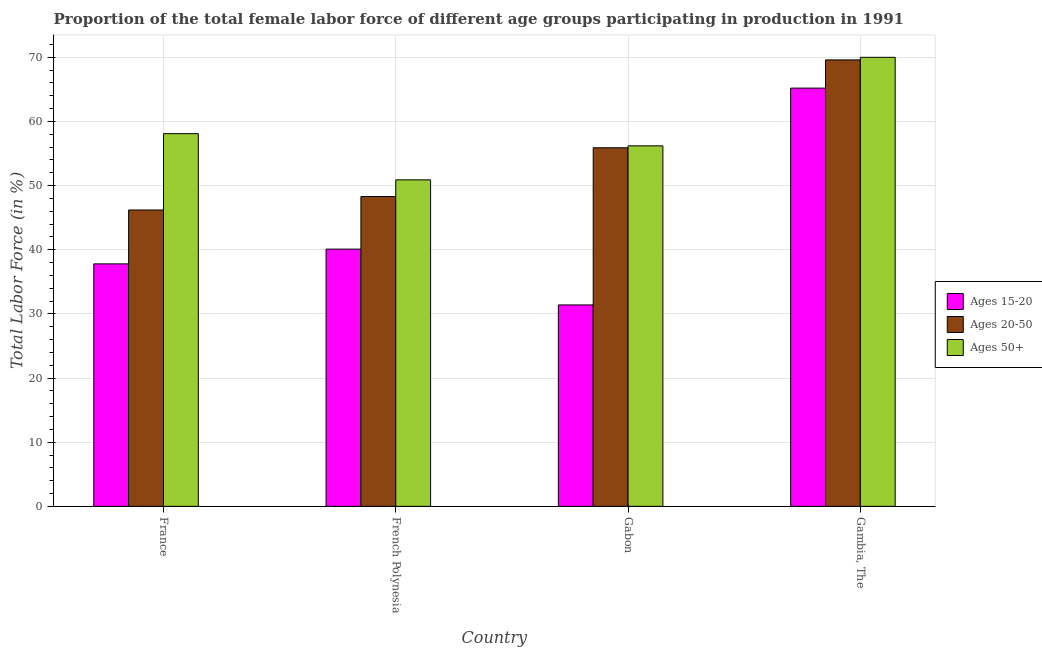How many different coloured bars are there?
Ensure brevity in your answer.  3. Are the number of bars on each tick of the X-axis equal?
Offer a terse response. Yes. How many bars are there on the 3rd tick from the right?
Provide a short and direct response. 3. What is the label of the 4th group of bars from the left?
Offer a very short reply. Gambia, The. In how many cases, is the number of bars for a given country not equal to the number of legend labels?
Ensure brevity in your answer.  0. What is the percentage of female labor force above age 50 in Gambia, The?
Offer a very short reply. 70. Across all countries, what is the maximum percentage of female labor force within the age group 20-50?
Keep it short and to the point. 69.6. Across all countries, what is the minimum percentage of female labor force within the age group 20-50?
Keep it short and to the point. 46.2. In which country was the percentage of female labor force within the age group 15-20 maximum?
Provide a succinct answer. Gambia, The. In which country was the percentage of female labor force within the age group 20-50 minimum?
Make the answer very short. France. What is the total percentage of female labor force within the age group 15-20 in the graph?
Give a very brief answer. 174.5. What is the difference between the percentage of female labor force within the age group 15-20 in France and that in Gambia, The?
Keep it short and to the point. -27.4. What is the difference between the percentage of female labor force within the age group 20-50 in French Polynesia and the percentage of female labor force within the age group 15-20 in Gabon?
Ensure brevity in your answer.  16.9. What is the average percentage of female labor force within the age group 15-20 per country?
Keep it short and to the point. 43.62. What is the difference between the percentage of female labor force within the age group 15-20 and percentage of female labor force within the age group 20-50 in France?
Offer a very short reply. -8.4. In how many countries, is the percentage of female labor force within the age group 20-50 greater than 36 %?
Your answer should be very brief. 4. What is the ratio of the percentage of female labor force within the age group 20-50 in Gabon to that in Gambia, The?
Your answer should be compact. 0.8. Is the percentage of female labor force within the age group 20-50 in Gabon less than that in Gambia, The?
Keep it short and to the point. Yes. Is the difference between the percentage of female labor force above age 50 in French Polynesia and Gambia, The greater than the difference between the percentage of female labor force within the age group 15-20 in French Polynesia and Gambia, The?
Your response must be concise. Yes. What is the difference between the highest and the second highest percentage of female labor force within the age group 15-20?
Provide a short and direct response. 25.1. What is the difference between the highest and the lowest percentage of female labor force above age 50?
Keep it short and to the point. 19.1. What does the 1st bar from the left in French Polynesia represents?
Your answer should be very brief. Ages 15-20. What does the 1st bar from the right in France represents?
Offer a terse response. Ages 50+. Is it the case that in every country, the sum of the percentage of female labor force within the age group 15-20 and percentage of female labor force within the age group 20-50 is greater than the percentage of female labor force above age 50?
Your answer should be very brief. Yes. How many bars are there?
Keep it short and to the point. 12. What is the difference between two consecutive major ticks on the Y-axis?
Offer a very short reply. 10. Does the graph contain any zero values?
Provide a short and direct response. No. Where does the legend appear in the graph?
Your response must be concise. Center right. What is the title of the graph?
Your response must be concise. Proportion of the total female labor force of different age groups participating in production in 1991. What is the Total Labor Force (in %) of Ages 15-20 in France?
Provide a short and direct response. 37.8. What is the Total Labor Force (in %) of Ages 20-50 in France?
Provide a short and direct response. 46.2. What is the Total Labor Force (in %) of Ages 50+ in France?
Provide a succinct answer. 58.1. What is the Total Labor Force (in %) of Ages 15-20 in French Polynesia?
Keep it short and to the point. 40.1. What is the Total Labor Force (in %) in Ages 20-50 in French Polynesia?
Keep it short and to the point. 48.3. What is the Total Labor Force (in %) of Ages 50+ in French Polynesia?
Your answer should be compact. 50.9. What is the Total Labor Force (in %) in Ages 15-20 in Gabon?
Make the answer very short. 31.4. What is the Total Labor Force (in %) of Ages 20-50 in Gabon?
Offer a terse response. 55.9. What is the Total Labor Force (in %) of Ages 50+ in Gabon?
Your answer should be very brief. 56.2. What is the Total Labor Force (in %) of Ages 15-20 in Gambia, The?
Offer a terse response. 65.2. What is the Total Labor Force (in %) in Ages 20-50 in Gambia, The?
Offer a very short reply. 69.6. Across all countries, what is the maximum Total Labor Force (in %) in Ages 15-20?
Keep it short and to the point. 65.2. Across all countries, what is the maximum Total Labor Force (in %) of Ages 20-50?
Ensure brevity in your answer.  69.6. Across all countries, what is the minimum Total Labor Force (in %) in Ages 15-20?
Provide a succinct answer. 31.4. Across all countries, what is the minimum Total Labor Force (in %) of Ages 20-50?
Give a very brief answer. 46.2. Across all countries, what is the minimum Total Labor Force (in %) in Ages 50+?
Provide a succinct answer. 50.9. What is the total Total Labor Force (in %) in Ages 15-20 in the graph?
Your answer should be very brief. 174.5. What is the total Total Labor Force (in %) of Ages 20-50 in the graph?
Offer a very short reply. 220. What is the total Total Labor Force (in %) in Ages 50+ in the graph?
Keep it short and to the point. 235.2. What is the difference between the Total Labor Force (in %) of Ages 15-20 in France and that in French Polynesia?
Provide a succinct answer. -2.3. What is the difference between the Total Labor Force (in %) of Ages 15-20 in France and that in Gabon?
Keep it short and to the point. 6.4. What is the difference between the Total Labor Force (in %) of Ages 50+ in France and that in Gabon?
Your answer should be very brief. 1.9. What is the difference between the Total Labor Force (in %) in Ages 15-20 in France and that in Gambia, The?
Offer a terse response. -27.4. What is the difference between the Total Labor Force (in %) in Ages 20-50 in France and that in Gambia, The?
Offer a terse response. -23.4. What is the difference between the Total Labor Force (in %) of Ages 15-20 in French Polynesia and that in Gambia, The?
Offer a very short reply. -25.1. What is the difference between the Total Labor Force (in %) of Ages 20-50 in French Polynesia and that in Gambia, The?
Offer a very short reply. -21.3. What is the difference between the Total Labor Force (in %) of Ages 50+ in French Polynesia and that in Gambia, The?
Give a very brief answer. -19.1. What is the difference between the Total Labor Force (in %) in Ages 15-20 in Gabon and that in Gambia, The?
Make the answer very short. -33.8. What is the difference between the Total Labor Force (in %) of Ages 20-50 in Gabon and that in Gambia, The?
Provide a short and direct response. -13.7. What is the difference between the Total Labor Force (in %) in Ages 15-20 in France and the Total Labor Force (in %) in Ages 50+ in French Polynesia?
Your response must be concise. -13.1. What is the difference between the Total Labor Force (in %) of Ages 20-50 in France and the Total Labor Force (in %) of Ages 50+ in French Polynesia?
Provide a short and direct response. -4.7. What is the difference between the Total Labor Force (in %) of Ages 15-20 in France and the Total Labor Force (in %) of Ages 20-50 in Gabon?
Offer a very short reply. -18.1. What is the difference between the Total Labor Force (in %) of Ages 15-20 in France and the Total Labor Force (in %) of Ages 50+ in Gabon?
Keep it short and to the point. -18.4. What is the difference between the Total Labor Force (in %) of Ages 15-20 in France and the Total Labor Force (in %) of Ages 20-50 in Gambia, The?
Your response must be concise. -31.8. What is the difference between the Total Labor Force (in %) of Ages 15-20 in France and the Total Labor Force (in %) of Ages 50+ in Gambia, The?
Your answer should be very brief. -32.2. What is the difference between the Total Labor Force (in %) in Ages 20-50 in France and the Total Labor Force (in %) in Ages 50+ in Gambia, The?
Keep it short and to the point. -23.8. What is the difference between the Total Labor Force (in %) in Ages 15-20 in French Polynesia and the Total Labor Force (in %) in Ages 20-50 in Gabon?
Offer a very short reply. -15.8. What is the difference between the Total Labor Force (in %) in Ages 15-20 in French Polynesia and the Total Labor Force (in %) in Ages 50+ in Gabon?
Make the answer very short. -16.1. What is the difference between the Total Labor Force (in %) of Ages 20-50 in French Polynesia and the Total Labor Force (in %) of Ages 50+ in Gabon?
Keep it short and to the point. -7.9. What is the difference between the Total Labor Force (in %) in Ages 15-20 in French Polynesia and the Total Labor Force (in %) in Ages 20-50 in Gambia, The?
Give a very brief answer. -29.5. What is the difference between the Total Labor Force (in %) in Ages 15-20 in French Polynesia and the Total Labor Force (in %) in Ages 50+ in Gambia, The?
Provide a short and direct response. -29.9. What is the difference between the Total Labor Force (in %) in Ages 20-50 in French Polynesia and the Total Labor Force (in %) in Ages 50+ in Gambia, The?
Ensure brevity in your answer.  -21.7. What is the difference between the Total Labor Force (in %) of Ages 15-20 in Gabon and the Total Labor Force (in %) of Ages 20-50 in Gambia, The?
Offer a very short reply. -38.2. What is the difference between the Total Labor Force (in %) in Ages 15-20 in Gabon and the Total Labor Force (in %) in Ages 50+ in Gambia, The?
Ensure brevity in your answer.  -38.6. What is the difference between the Total Labor Force (in %) in Ages 20-50 in Gabon and the Total Labor Force (in %) in Ages 50+ in Gambia, The?
Give a very brief answer. -14.1. What is the average Total Labor Force (in %) in Ages 15-20 per country?
Give a very brief answer. 43.62. What is the average Total Labor Force (in %) of Ages 20-50 per country?
Keep it short and to the point. 55. What is the average Total Labor Force (in %) of Ages 50+ per country?
Your response must be concise. 58.8. What is the difference between the Total Labor Force (in %) of Ages 15-20 and Total Labor Force (in %) of Ages 20-50 in France?
Provide a short and direct response. -8.4. What is the difference between the Total Labor Force (in %) of Ages 15-20 and Total Labor Force (in %) of Ages 50+ in France?
Offer a very short reply. -20.3. What is the difference between the Total Labor Force (in %) in Ages 20-50 and Total Labor Force (in %) in Ages 50+ in France?
Your response must be concise. -11.9. What is the difference between the Total Labor Force (in %) of Ages 15-20 and Total Labor Force (in %) of Ages 20-50 in French Polynesia?
Provide a short and direct response. -8.2. What is the difference between the Total Labor Force (in %) of Ages 15-20 and Total Labor Force (in %) of Ages 50+ in French Polynesia?
Offer a very short reply. -10.8. What is the difference between the Total Labor Force (in %) in Ages 15-20 and Total Labor Force (in %) in Ages 20-50 in Gabon?
Your response must be concise. -24.5. What is the difference between the Total Labor Force (in %) in Ages 15-20 and Total Labor Force (in %) in Ages 50+ in Gabon?
Provide a succinct answer. -24.8. What is the difference between the Total Labor Force (in %) in Ages 20-50 and Total Labor Force (in %) in Ages 50+ in Gabon?
Offer a terse response. -0.3. What is the difference between the Total Labor Force (in %) of Ages 15-20 and Total Labor Force (in %) of Ages 20-50 in Gambia, The?
Give a very brief answer. -4.4. What is the difference between the Total Labor Force (in %) of Ages 20-50 and Total Labor Force (in %) of Ages 50+ in Gambia, The?
Make the answer very short. -0.4. What is the ratio of the Total Labor Force (in %) of Ages 15-20 in France to that in French Polynesia?
Offer a very short reply. 0.94. What is the ratio of the Total Labor Force (in %) in Ages 20-50 in France to that in French Polynesia?
Ensure brevity in your answer.  0.96. What is the ratio of the Total Labor Force (in %) in Ages 50+ in France to that in French Polynesia?
Provide a succinct answer. 1.14. What is the ratio of the Total Labor Force (in %) of Ages 15-20 in France to that in Gabon?
Your answer should be very brief. 1.2. What is the ratio of the Total Labor Force (in %) of Ages 20-50 in France to that in Gabon?
Offer a terse response. 0.83. What is the ratio of the Total Labor Force (in %) in Ages 50+ in France to that in Gabon?
Make the answer very short. 1.03. What is the ratio of the Total Labor Force (in %) in Ages 15-20 in France to that in Gambia, The?
Ensure brevity in your answer.  0.58. What is the ratio of the Total Labor Force (in %) in Ages 20-50 in France to that in Gambia, The?
Give a very brief answer. 0.66. What is the ratio of the Total Labor Force (in %) in Ages 50+ in France to that in Gambia, The?
Your answer should be compact. 0.83. What is the ratio of the Total Labor Force (in %) in Ages 15-20 in French Polynesia to that in Gabon?
Your response must be concise. 1.28. What is the ratio of the Total Labor Force (in %) in Ages 20-50 in French Polynesia to that in Gabon?
Your answer should be compact. 0.86. What is the ratio of the Total Labor Force (in %) of Ages 50+ in French Polynesia to that in Gabon?
Provide a succinct answer. 0.91. What is the ratio of the Total Labor Force (in %) in Ages 15-20 in French Polynesia to that in Gambia, The?
Your answer should be compact. 0.61. What is the ratio of the Total Labor Force (in %) in Ages 20-50 in French Polynesia to that in Gambia, The?
Provide a succinct answer. 0.69. What is the ratio of the Total Labor Force (in %) in Ages 50+ in French Polynesia to that in Gambia, The?
Keep it short and to the point. 0.73. What is the ratio of the Total Labor Force (in %) in Ages 15-20 in Gabon to that in Gambia, The?
Your response must be concise. 0.48. What is the ratio of the Total Labor Force (in %) in Ages 20-50 in Gabon to that in Gambia, The?
Offer a terse response. 0.8. What is the ratio of the Total Labor Force (in %) in Ages 50+ in Gabon to that in Gambia, The?
Make the answer very short. 0.8. What is the difference between the highest and the second highest Total Labor Force (in %) in Ages 15-20?
Your answer should be compact. 25.1. What is the difference between the highest and the second highest Total Labor Force (in %) in Ages 50+?
Ensure brevity in your answer.  11.9. What is the difference between the highest and the lowest Total Labor Force (in %) in Ages 15-20?
Keep it short and to the point. 33.8. What is the difference between the highest and the lowest Total Labor Force (in %) in Ages 20-50?
Your answer should be very brief. 23.4. What is the difference between the highest and the lowest Total Labor Force (in %) in Ages 50+?
Your answer should be compact. 19.1. 